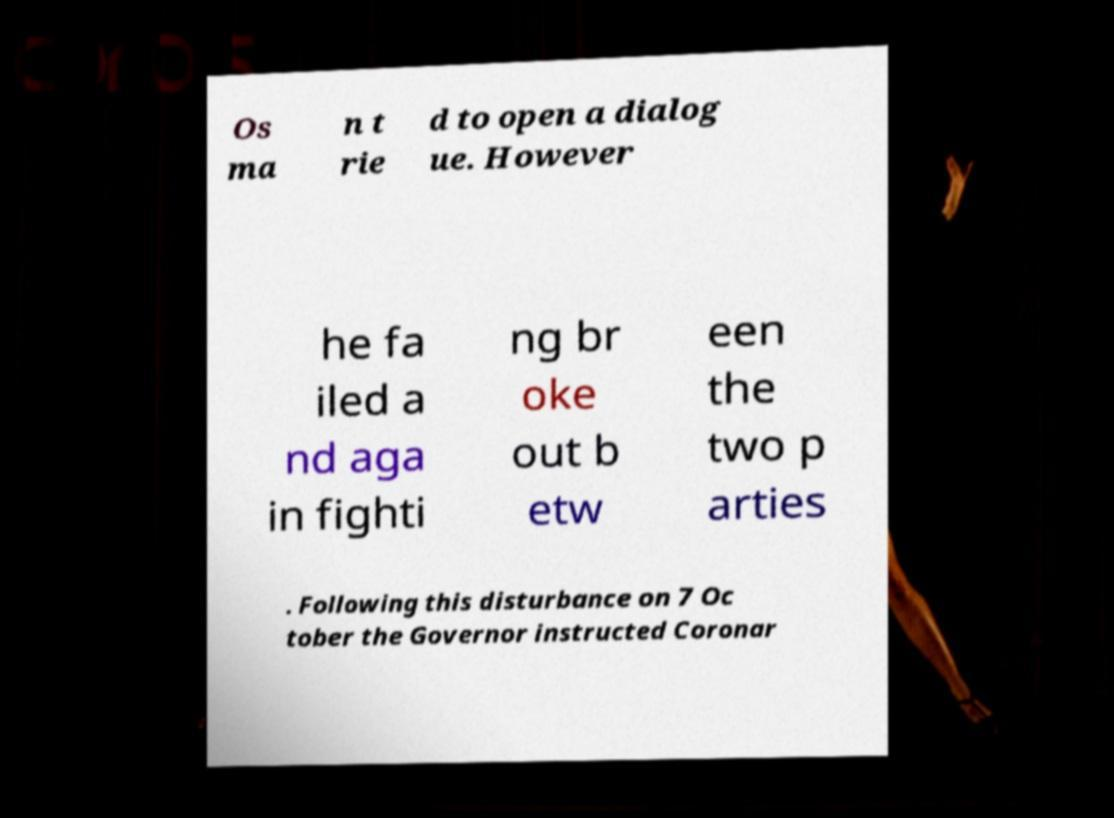Please read and relay the text visible in this image. What does it say? Os ma n t rie d to open a dialog ue. However he fa iled a nd aga in fighti ng br oke out b etw een the two p arties . Following this disturbance on 7 Oc tober the Governor instructed Coronar 